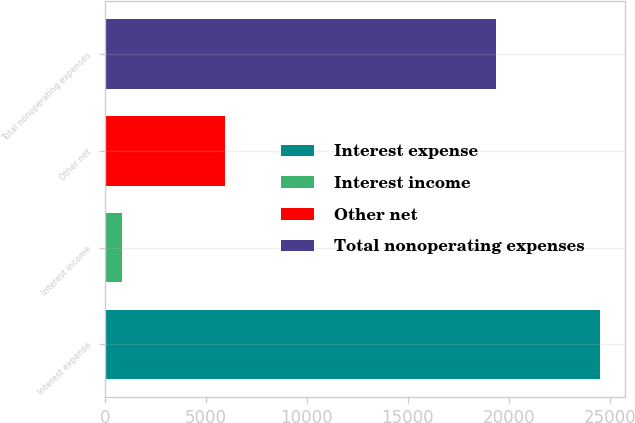Convert chart to OTSL. <chart><loc_0><loc_0><loc_500><loc_500><bar_chart><fcel>Interest expense<fcel>Interest income<fcel>Other net<fcel>Total nonoperating expenses<nl><fcel>24514<fcel>846<fcel>5965<fcel>19395<nl></chart> 